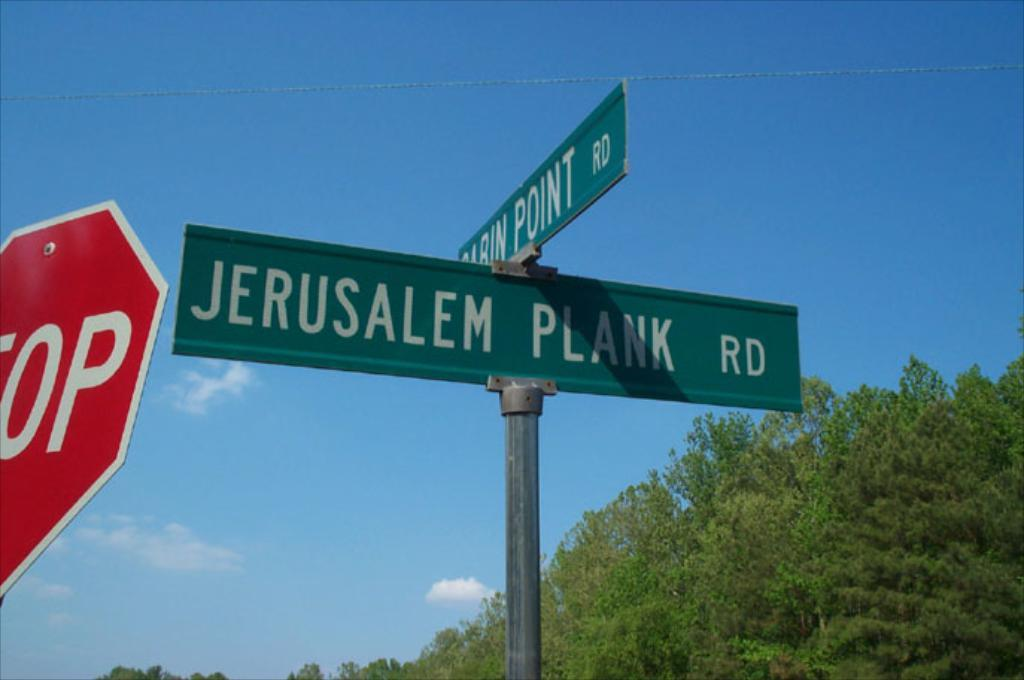<image>
Provide a brief description of the given image. A street sign marks Jerusalem Plank road with a stop sign nearby. 